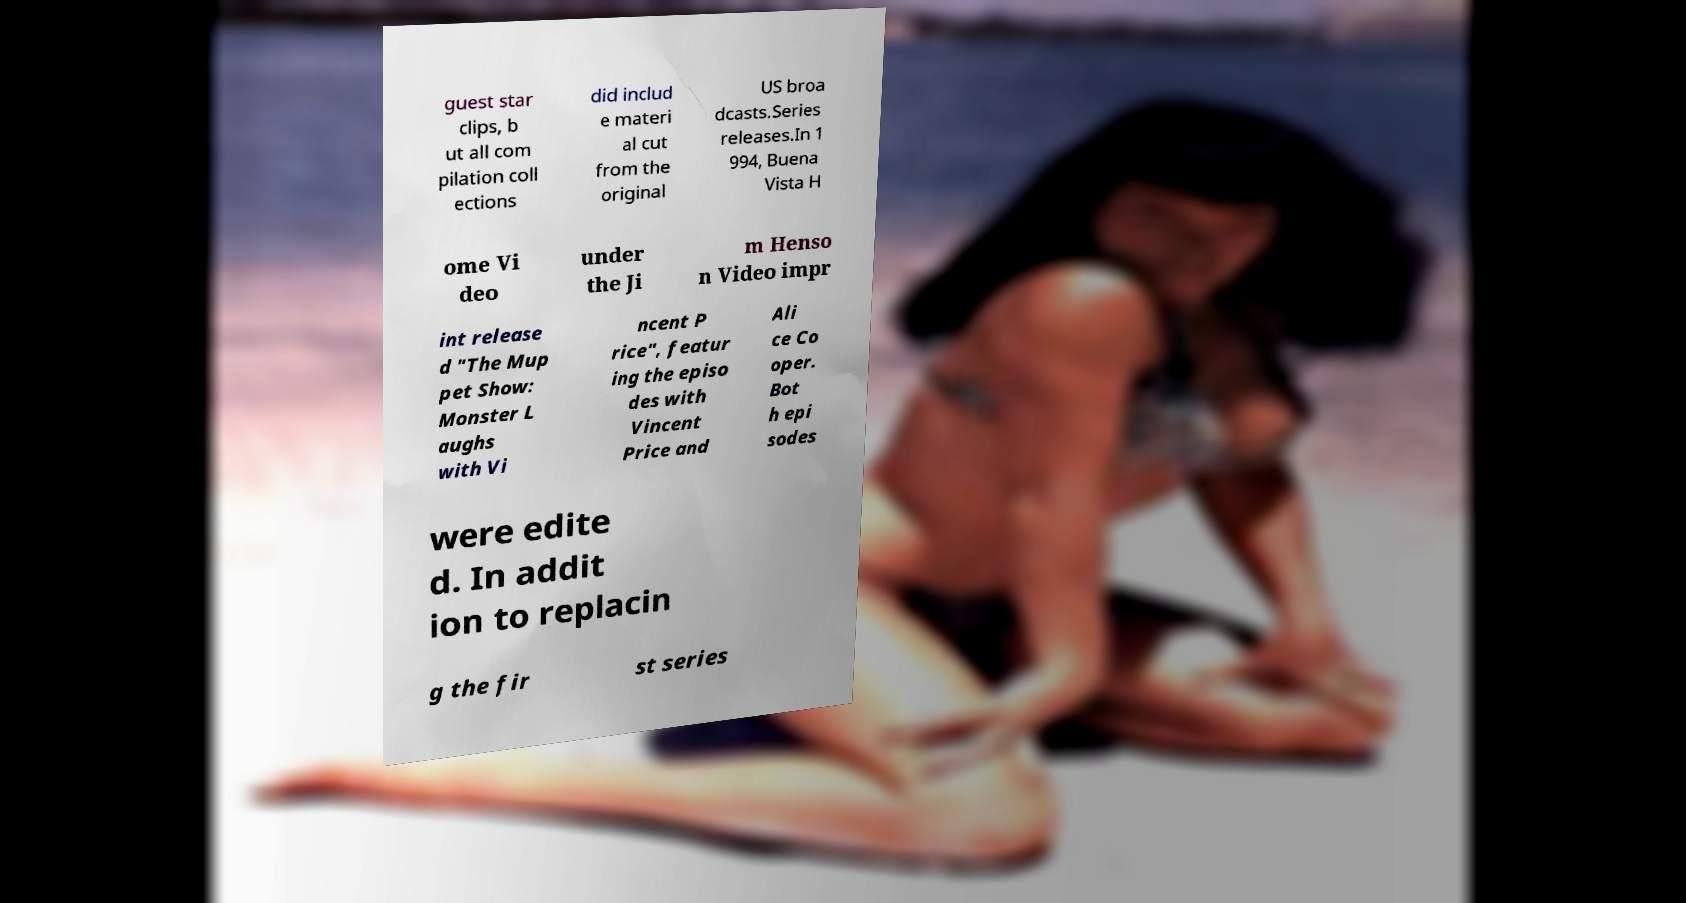Can you accurately transcribe the text from the provided image for me? guest star clips, b ut all com pilation coll ections did includ e materi al cut from the original US broa dcasts.Series releases.In 1 994, Buena Vista H ome Vi deo under the Ji m Henso n Video impr int release d "The Mup pet Show: Monster L aughs with Vi ncent P rice", featur ing the episo des with Vincent Price and Ali ce Co oper. Bot h epi sodes were edite d. In addit ion to replacin g the fir st series 